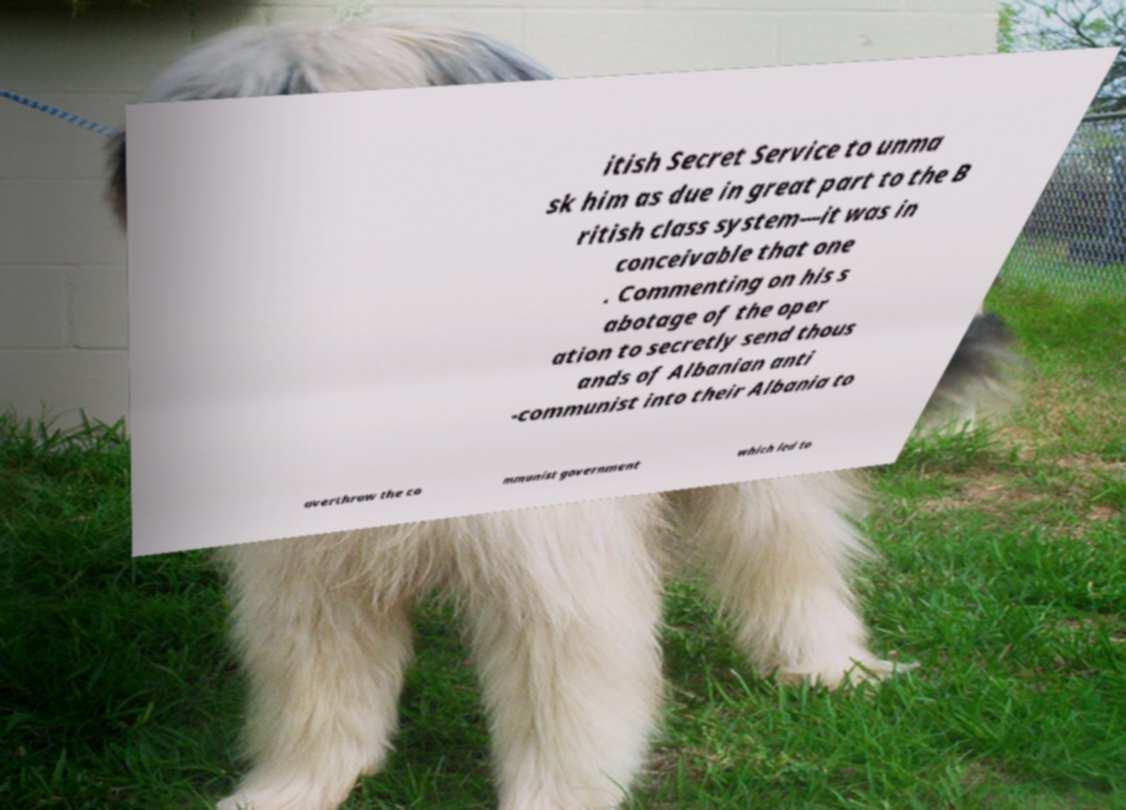There's text embedded in this image that I need extracted. Can you transcribe it verbatim? itish Secret Service to unma sk him as due in great part to the B ritish class system—it was in conceivable that one . Commenting on his s abotage of the oper ation to secretly send thous ands of Albanian anti -communist into their Albania to overthrow the co mmunist government which led to 